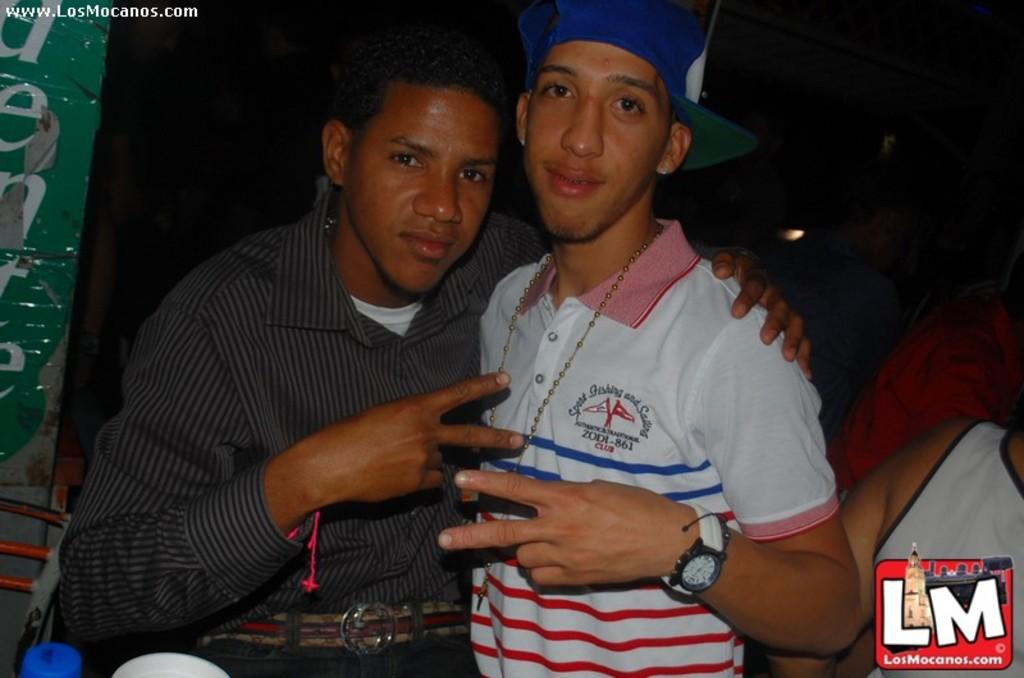<image>
Create a compact narrative representing the image presented. Two young men with arms around each other and ZODI*861 on his shirt. 